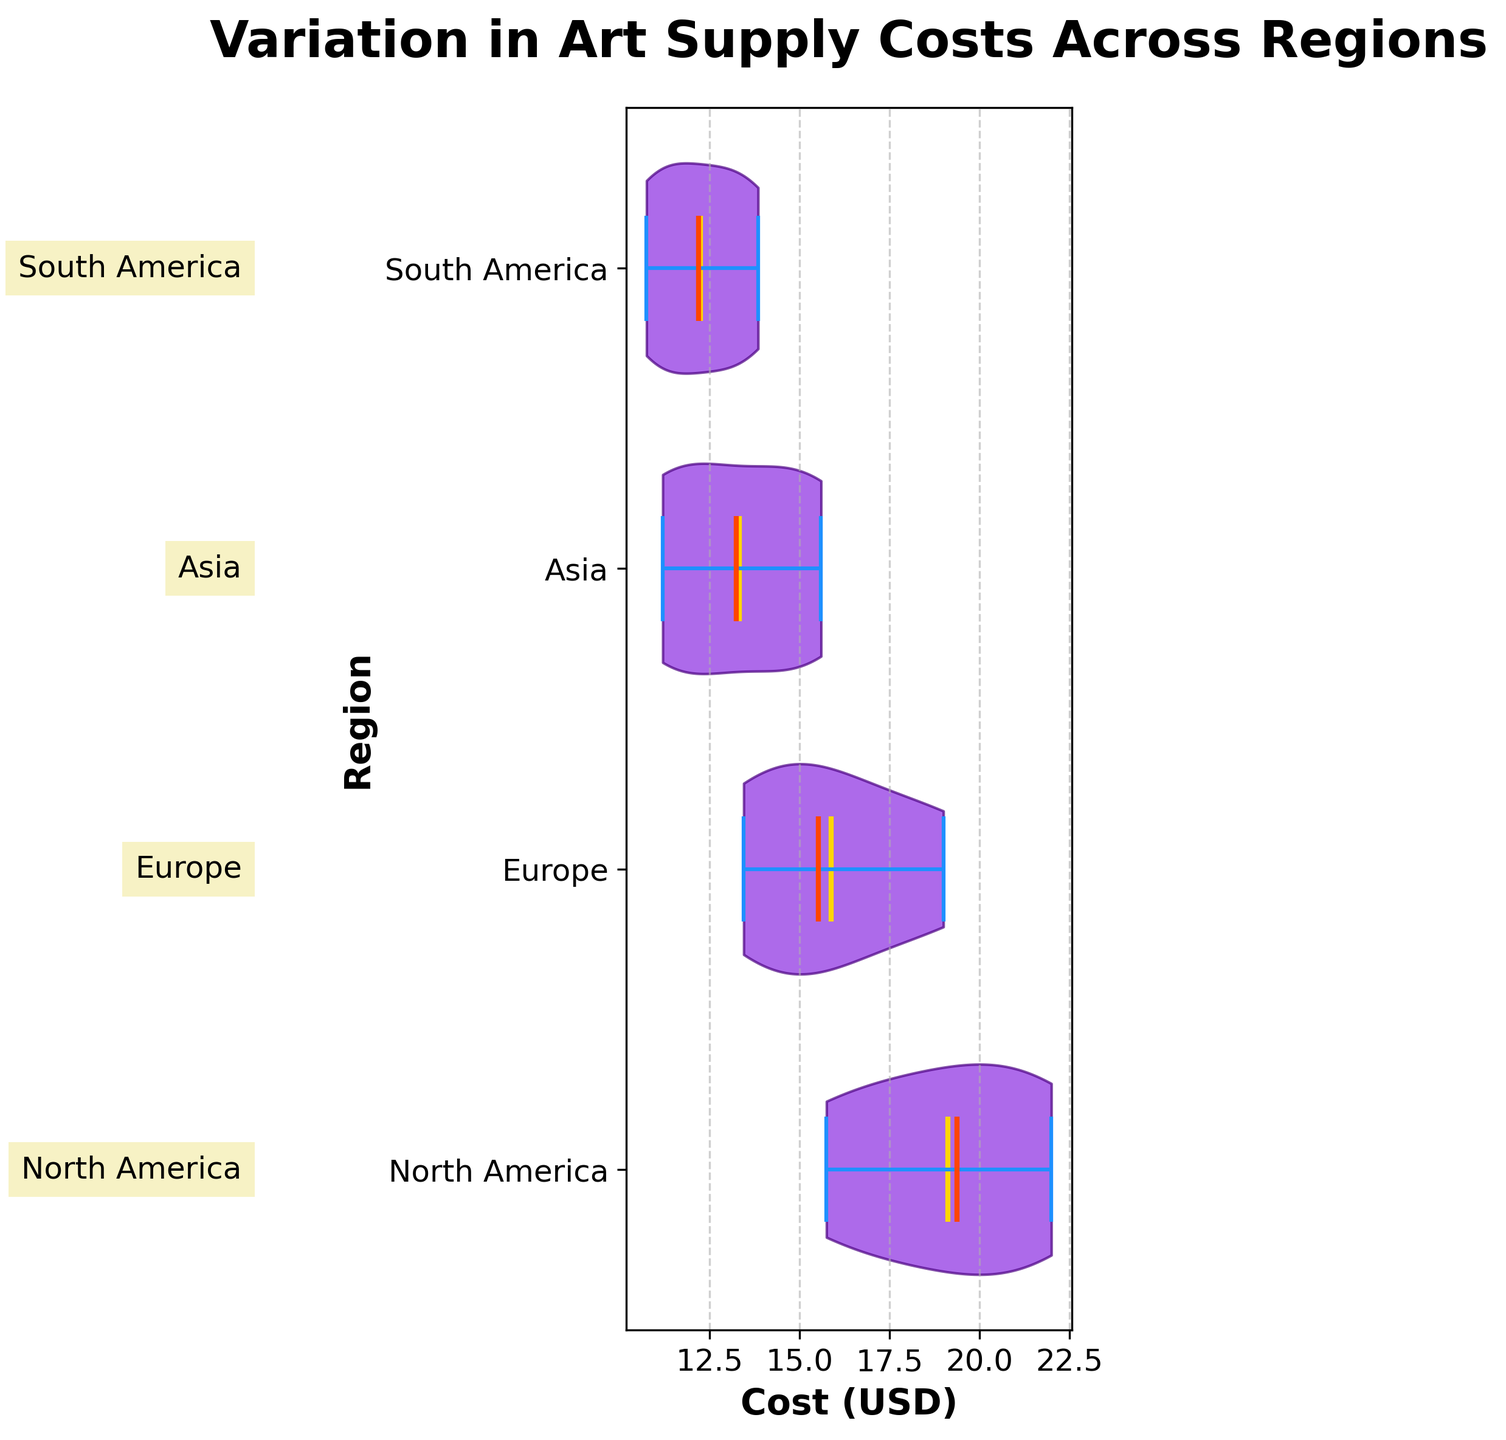What is the title of the figure? The title is located at the top of the figure and is in bold font, indicating what the chart is about.
Answer: Variation in Art Supply Costs Across Regions Which region has the lowest median cost? The median is indicated by the orange line in each violin plot. By comparing these medians, we can identify the lowest one.
Answer: South America What is the color of the mean markers in the chart? The mean markers are represented by a distinct color in the violin plot, which helps in quickly identifying the average values.
Answer: Gold Which region shows the highest variation in art supply costs? The range of the violin plot's shape and the length of the blue bars on either side of the violin plot's mean line give a clear indication of variability.
Answer: North America How does the cost distribution in Europe compare to Asia? Compare the middle range, spread, and individual shapes of the violin plots for Europe and Asia to see how the distributions differ. Europe has a slightly wider spread than Asia but both regions have similar concentration ranges.
Answer: Europe's spread is slightly wider Which region has the smallest range in cost values? The range can be inferred from the length of the blue bars representing the minima and maxima in each violin plot.
Answer: South America How many regions are displayed in the chart? Counting the number of distinct violin plots along the Y-axis will give us the number of regions being compared.
Answer: Four What is the approximate mean cost for art supplies in North America? The mean is indicated by the gold line within the violin plot. By observing its position relative to the X-axis values, we can estimate it.
Answer: Around $19 How do the medians of the costs compare between North America and South America? Compare the positions of the red median lines within the violin plots for North America and South America.
Answer: North America's median is higher than South America's median Which region has the highest mean cost, and what is that mean value? Identify the region with the highest gold mean line and then read the approximate value from the X-axis.
Answer: North America, around $19 